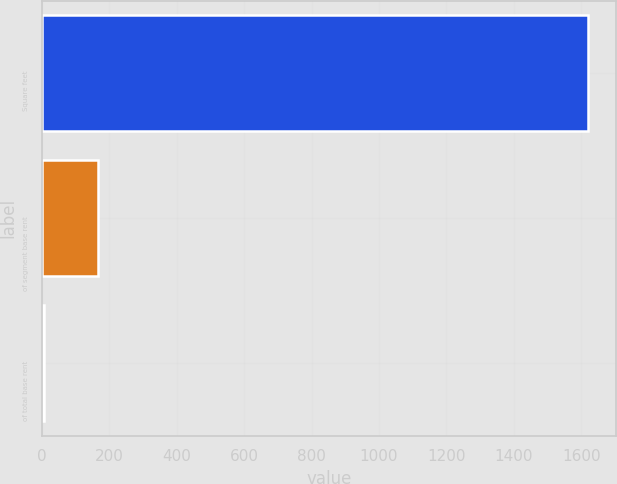Convert chart to OTSL. <chart><loc_0><loc_0><loc_500><loc_500><bar_chart><fcel>Square feet<fcel>of segment base rent<fcel>of total base rent<nl><fcel>1621<fcel>166.6<fcel>5<nl></chart> 